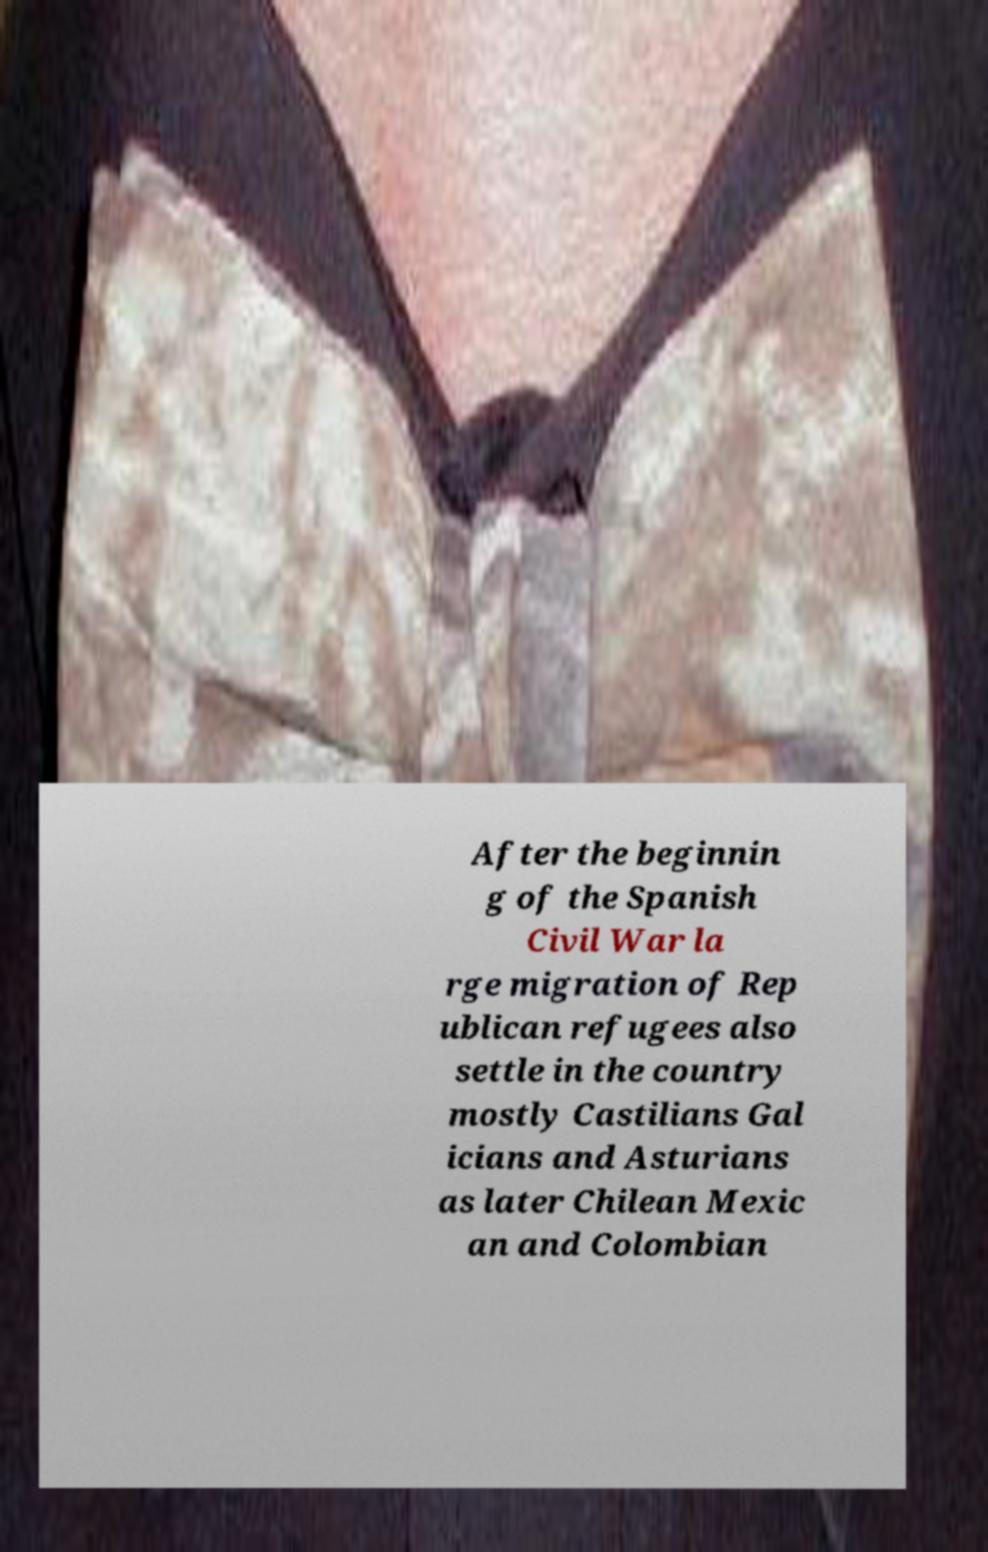Could you assist in decoding the text presented in this image and type it out clearly? After the beginnin g of the Spanish Civil War la rge migration of Rep ublican refugees also settle in the country mostly Castilians Gal icians and Asturians as later Chilean Mexic an and Colombian 